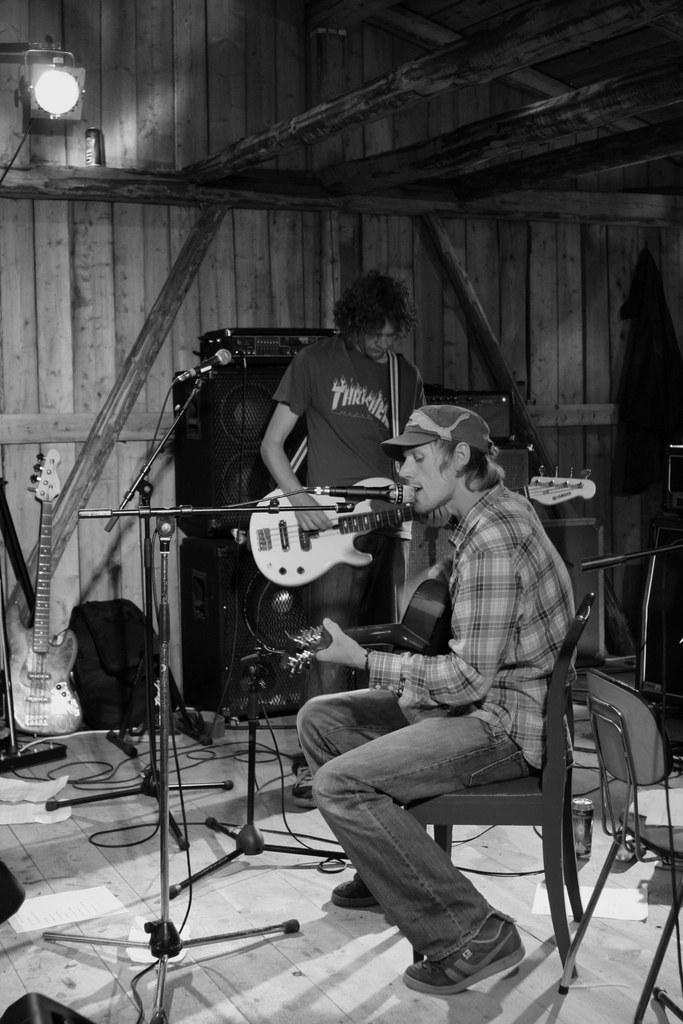Please provide a concise description of this image. In the picture we can find one man is sitting on the chair and sitting the song in the microphone. In the background we can find another man holding the guitar and there is light connected to wooden wall and some guitars on the floor. 